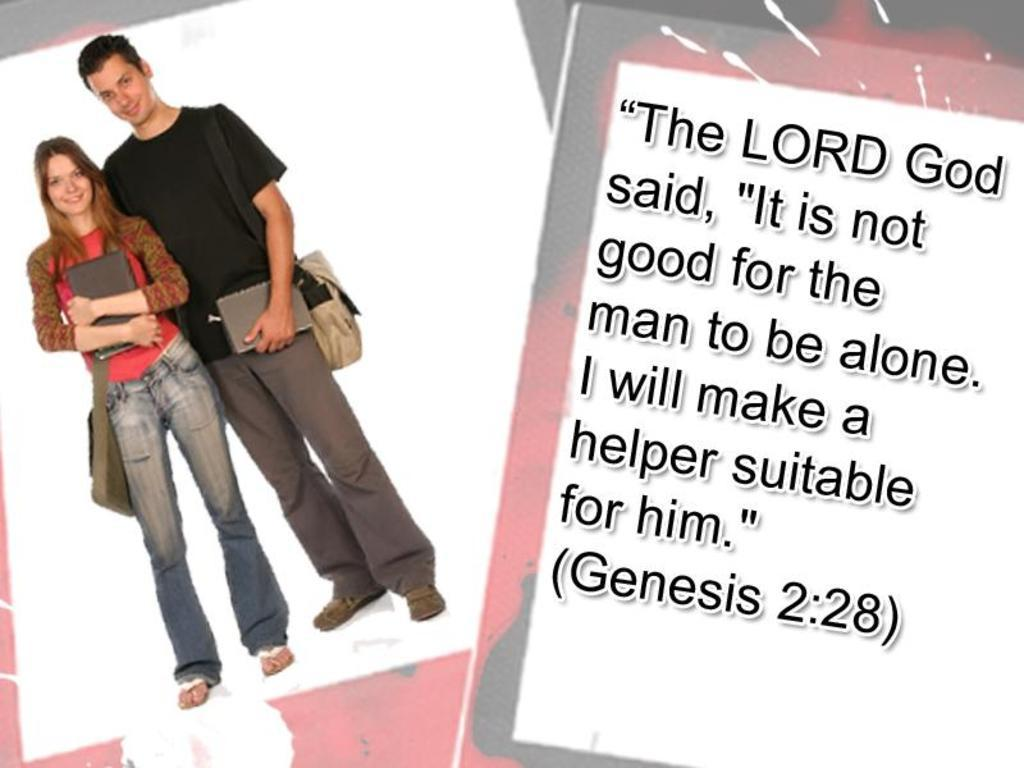How many people are in the image? There are two people in the image. What are the two people wearing? The two people are wearing bags. What are the two people holding? The two people are holding objects. Can you read any text in the image? Yes, there is some text visible in the image. Are there any jellyfish attacking the people in the image? No, there are no jellyfish present in the image, and therefore no such attack can be observed. 